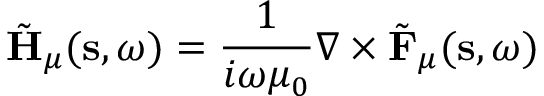<formula> <loc_0><loc_0><loc_500><loc_500>\tilde { H } _ { \mu } ( s , \omega ) = \frac { 1 } { i \omega \mu _ { 0 } } \nabla \times \tilde { F } _ { \mu } ( s , \omega )</formula> 